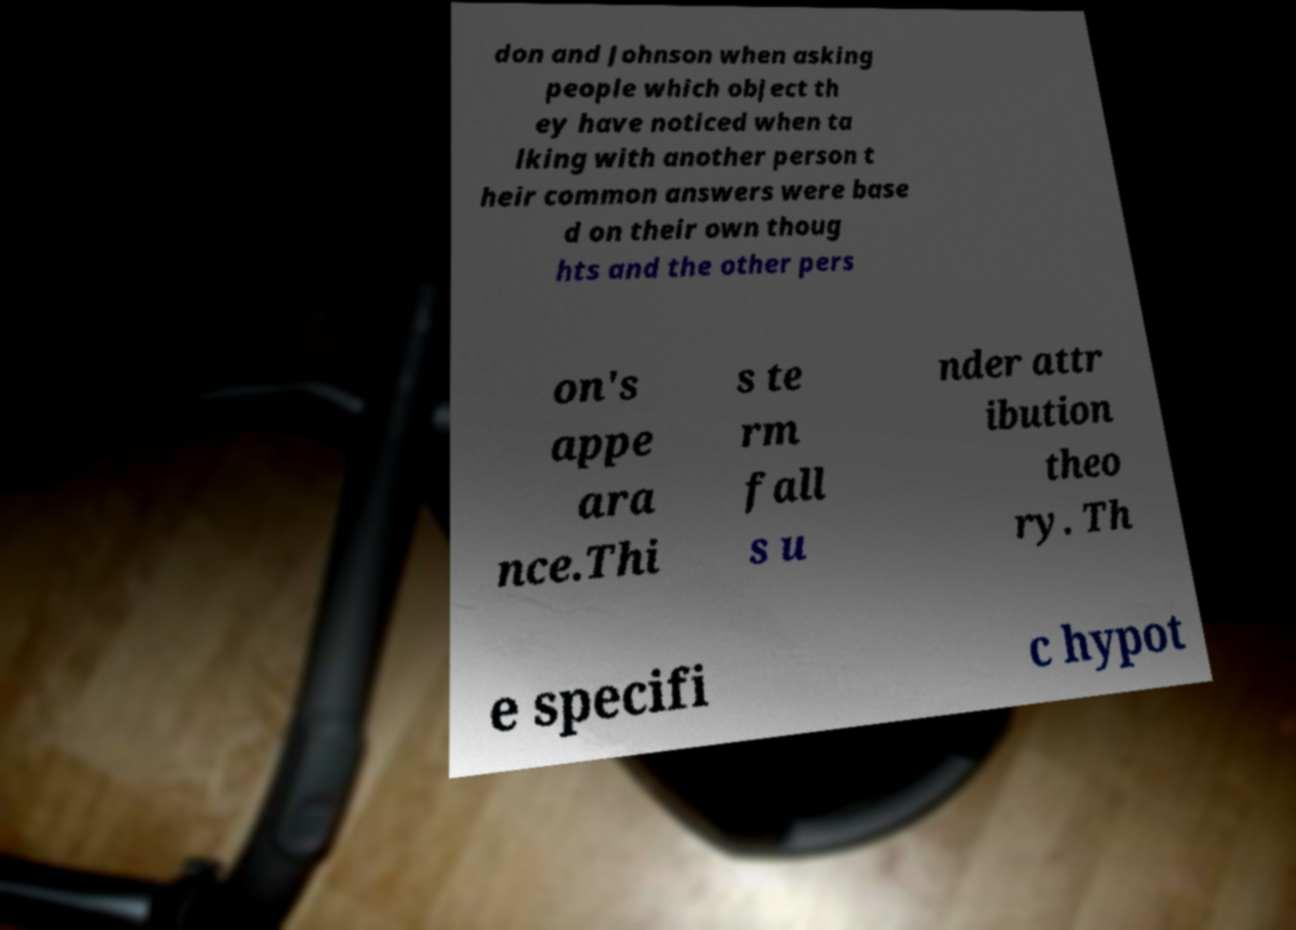What messages or text are displayed in this image? I need them in a readable, typed format. don and Johnson when asking people which object th ey have noticed when ta lking with another person t heir common answers were base d on their own thoug hts and the other pers on's appe ara nce.Thi s te rm fall s u nder attr ibution theo ry. Th e specifi c hypot 